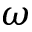Convert formula to latex. <formula><loc_0><loc_0><loc_500><loc_500>\omega</formula> 